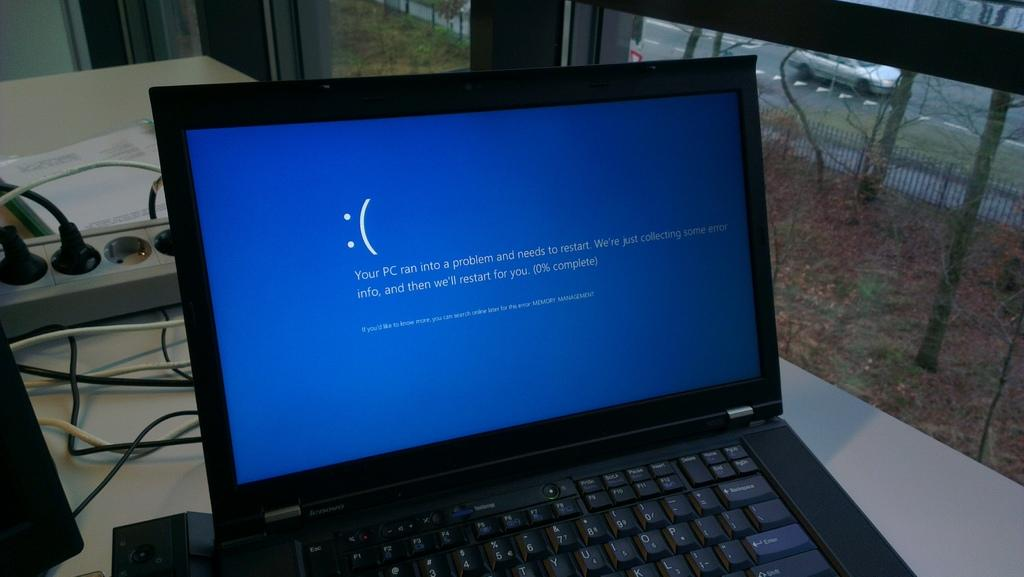Provide a one-sentence caption for the provided image. Someone's computer ran into a problem and needs to restart. 